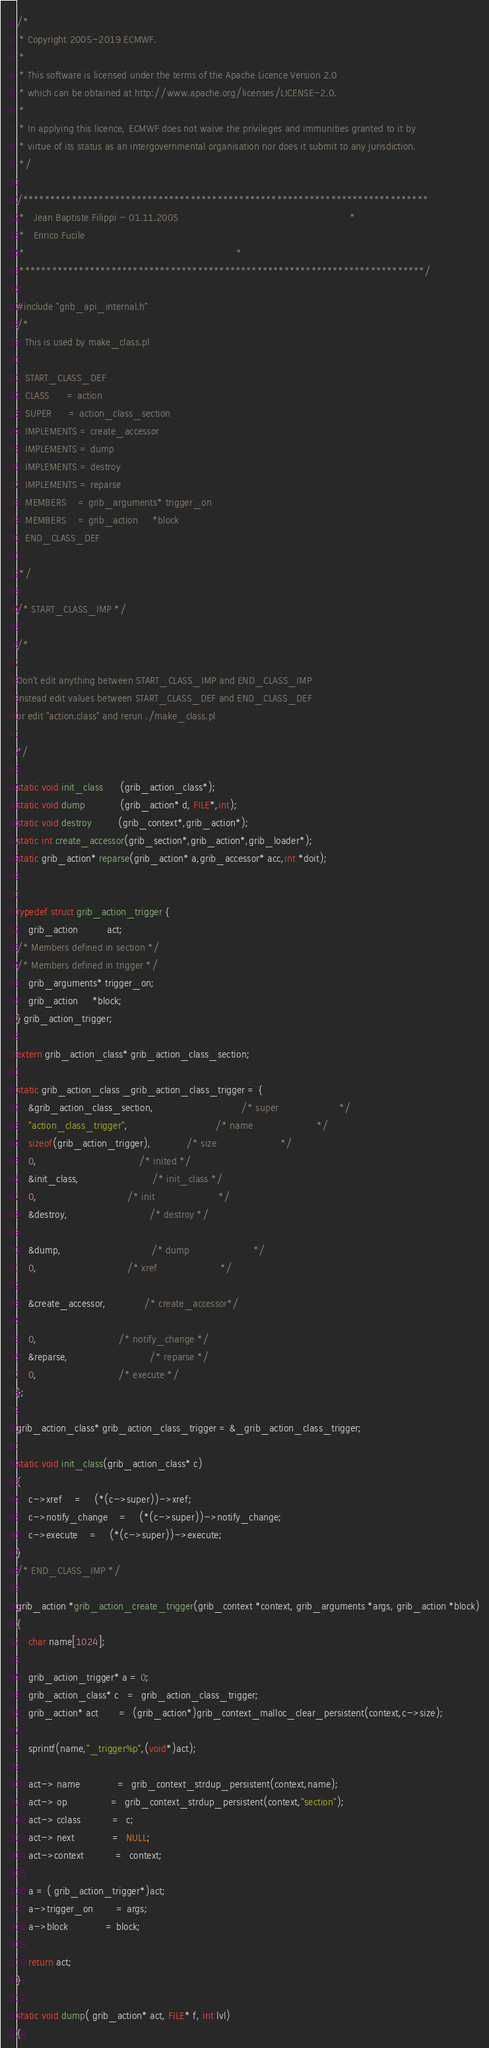<code> <loc_0><loc_0><loc_500><loc_500><_C_>/*
 * Copyright 2005-2019 ECMWF.
 *
 * This software is licensed under the terms of the Apache Licence Version 2.0
 * which can be obtained at http://www.apache.org/licenses/LICENSE-2.0.
 *
 * In applying this licence, ECMWF does not waive the privileges and immunities granted to it by
 * virtue of its status as an intergovernmental organisation nor does it submit to any jurisdiction.
 */

/***************************************************************************
 *   Jean Baptiste Filippi - 01.11.2005                                                           *
 *   Enrico Fucile
 *                                                                         *
 ***************************************************************************/

#include "grib_api_internal.h"
/*
   This is used by make_class.pl

   START_CLASS_DEF
   CLASS      = action
   SUPER      = action_class_section
   IMPLEMENTS = create_accessor
   IMPLEMENTS = dump
   IMPLEMENTS = destroy
   IMPLEMENTS = reparse
   MEMBERS    = grib_arguments* trigger_on
   MEMBERS    = grib_action     *block
   END_CLASS_DEF

 */

/* START_CLASS_IMP */

/*

Don't edit anything between START_CLASS_IMP and END_CLASS_IMP
Instead edit values between START_CLASS_DEF and END_CLASS_DEF
or edit "action.class" and rerun ./make_class.pl

*/

static void init_class      (grib_action_class*);
static void dump            (grib_action* d, FILE*,int);
static void destroy         (grib_context*,grib_action*);
static int create_accessor(grib_section*,grib_action*,grib_loader*);
static grib_action* reparse(grib_action* a,grib_accessor* acc,int *doit);


typedef struct grib_action_trigger {
    grib_action          act;  
/* Members defined in section */
/* Members defined in trigger */
	grib_arguments* trigger_on;
	grib_action     *block;
} grib_action_trigger;

extern grib_action_class* grib_action_class_section;

static grib_action_class _grib_action_class_trigger = {
    &grib_action_class_section,                              /* super                     */
    "action_class_trigger",                              /* name                      */
    sizeof(grib_action_trigger),            /* size                      */
    0,                                   /* inited */
    &init_class,                         /* init_class */
    0,                               /* init                      */
    &destroy,                            /* destroy */

    &dump,                               /* dump                      */
    0,                               /* xref                      */

    &create_accessor,             /* create_accessor*/

    0,                            /* notify_change */
    &reparse,                            /* reparse */
    0,                            /* execute */
};

grib_action_class* grib_action_class_trigger = &_grib_action_class_trigger;

static void init_class(grib_action_class* c)
{
	c->xref	=	(*(c->super))->xref;
	c->notify_change	=	(*(c->super))->notify_change;
	c->execute	=	(*(c->super))->execute;
}
/* END_CLASS_IMP */

grib_action *grib_action_create_trigger(grib_context *context, grib_arguments *args, grib_action *block)
{
    char name[1024];

    grib_action_trigger* a = 0;
    grib_action_class* c   =  grib_action_class_trigger;
    grib_action* act       =  (grib_action*)grib_context_malloc_clear_persistent(context,c->size);

    sprintf(name,"_trigger%p",(void*)act);

    act-> name             =  grib_context_strdup_persistent(context,name);
    act-> op               =  grib_context_strdup_persistent(context,"section");
    act-> cclass           =  c;
    act-> next             =  NULL;
    act->context           =  context;

    a = ( grib_action_trigger*)act;
    a->trigger_on        = args;
    a->block             = block;

    return act;
}

static void dump( grib_action* act, FILE* f, int lvl)
{</code> 